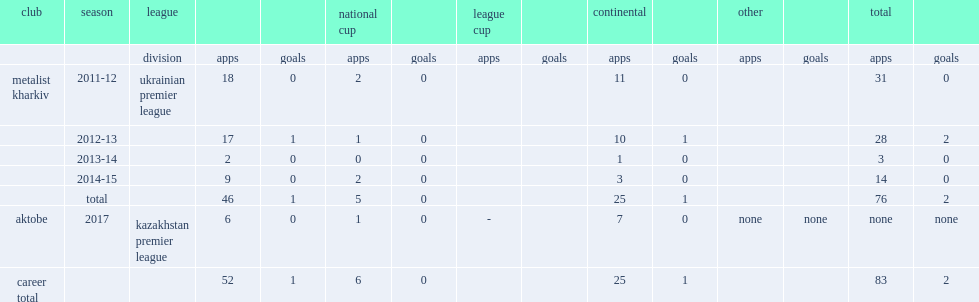In 2017, which league did torres join in side fc aktobe? Kazakhstan premier league. 